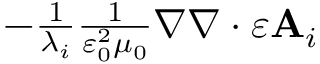<formula> <loc_0><loc_0><loc_500><loc_500>\begin{array} { r } { - \frac { 1 } { \lambda _ { i } } \frac { 1 } { \varepsilon _ { 0 } ^ { 2 } \mu _ { 0 } } \nabla \nabla \cdot \varepsilon A _ { i } } \end{array}</formula> 